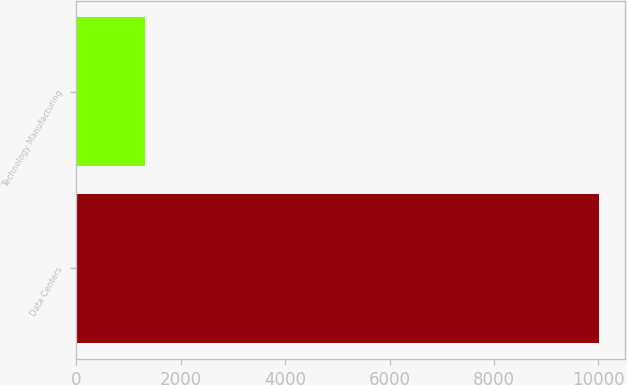Convert chart. <chart><loc_0><loc_0><loc_500><loc_500><bar_chart><fcel>Data Centers<fcel>Technology Manufacturing<nl><fcel>10014<fcel>1321<nl></chart> 